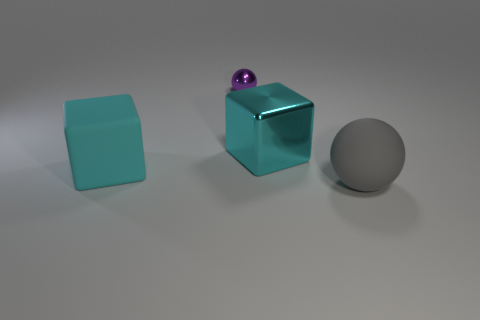Add 3 large gray matte objects. How many objects exist? 7 Subtract all purple spheres. How many spheres are left? 1 Subtract all small yellow metallic spheres. Subtract all balls. How many objects are left? 2 Add 2 large matte cubes. How many large matte cubes are left? 3 Add 2 cyan metal things. How many cyan metal things exist? 3 Subtract 0 brown cylinders. How many objects are left? 4 Subtract 2 cubes. How many cubes are left? 0 Subtract all brown spheres. Subtract all yellow cubes. How many spheres are left? 2 